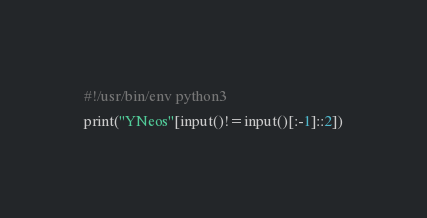Convert code to text. <code><loc_0><loc_0><loc_500><loc_500><_Python_>#!/usr/bin/env python3
print("YNeos"[input()!=input()[:-1]::2])</code> 